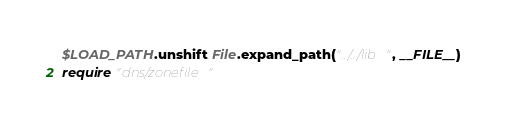Convert code to text. <code><loc_0><loc_0><loc_500><loc_500><_Ruby_>$LOAD_PATH.unshift File.expand_path("../../lib", __FILE__)
require "dns/zonefile"
</code> 